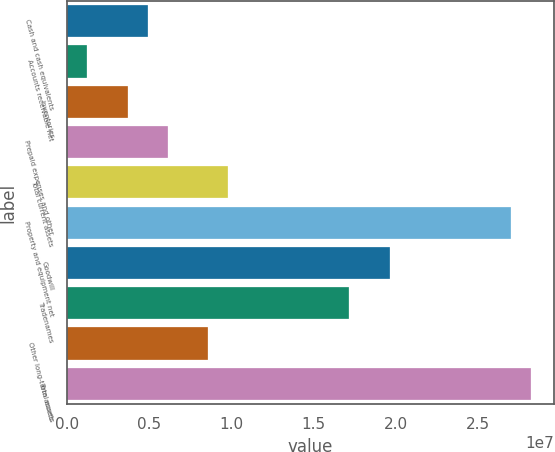Convert chart. <chart><loc_0><loc_0><loc_500><loc_500><bar_chart><fcel>Cash and cash equivalents<fcel>Accounts receivable net<fcel>Inventories<fcel>Prepaid expenses and other<fcel>Total current assets<fcel>Property and equipment net<fcel>Goodwill<fcel>Tradenames<fcel>Other long-term assets<fcel>Total assets<nl><fcel>4.90604e+06<fcel>1.22668e+06<fcel>3.67959e+06<fcel>6.13249e+06<fcel>9.81185e+06<fcel>2.69822e+07<fcel>1.96235e+07<fcel>1.71706e+07<fcel>8.5854e+06<fcel>2.82086e+07<nl></chart> 